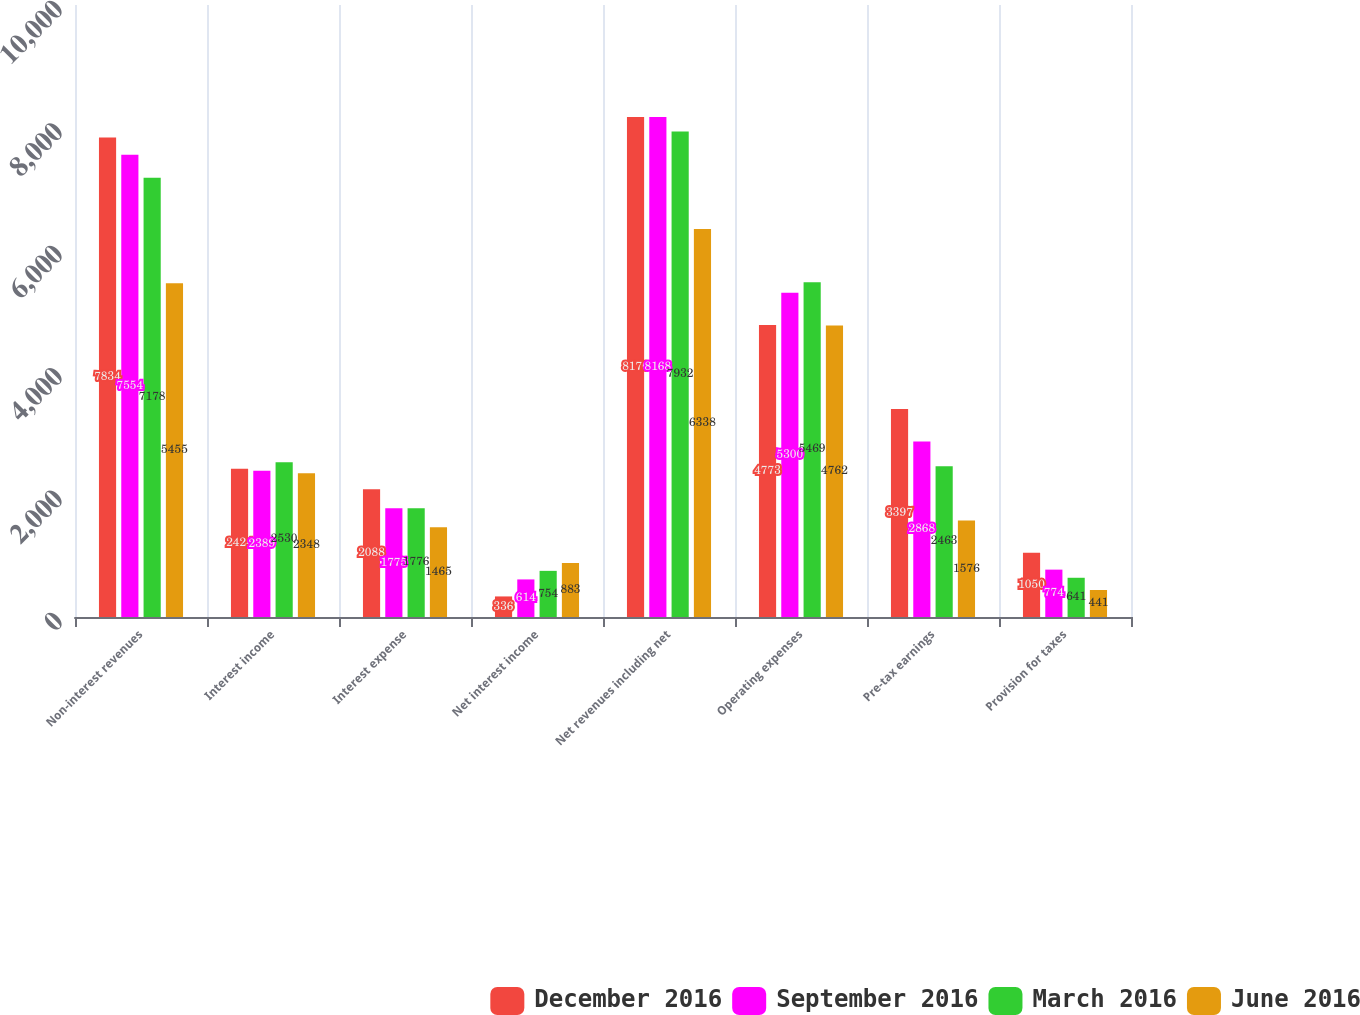Convert chart. <chart><loc_0><loc_0><loc_500><loc_500><stacked_bar_chart><ecel><fcel>Non-interest revenues<fcel>Interest income<fcel>Interest expense<fcel>Net interest income<fcel>Net revenues including net<fcel>Operating expenses<fcel>Pre-tax earnings<fcel>Provision for taxes<nl><fcel>December 2016<fcel>7834<fcel>2424<fcel>2088<fcel>336<fcel>8170<fcel>4773<fcel>3397<fcel>1050<nl><fcel>September 2016<fcel>7554<fcel>2389<fcel>1775<fcel>614<fcel>8168<fcel>5300<fcel>2868<fcel>774<nl><fcel>March 2016<fcel>7178<fcel>2530<fcel>1776<fcel>754<fcel>7932<fcel>5469<fcel>2463<fcel>641<nl><fcel>June 2016<fcel>5455<fcel>2348<fcel>1465<fcel>883<fcel>6338<fcel>4762<fcel>1576<fcel>441<nl></chart> 